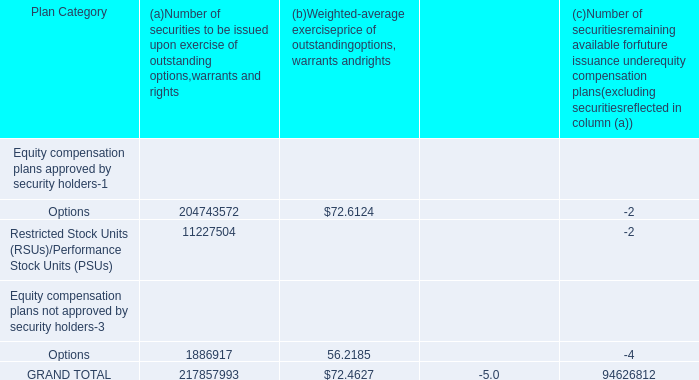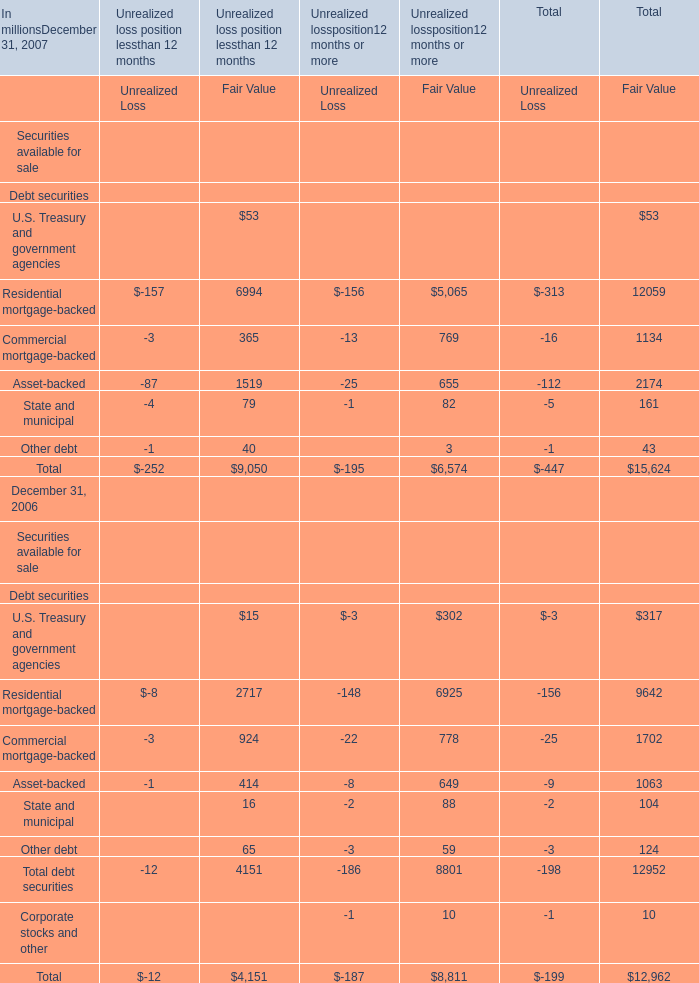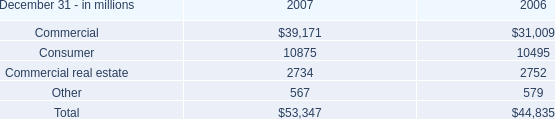what was the change in commercial commitments net of participations , assignments and syndications , primarily to financial services companies in 2007 compared to 2006 in billions? 
Computations: (8.9 - 8.3)
Answer: 0.6. 